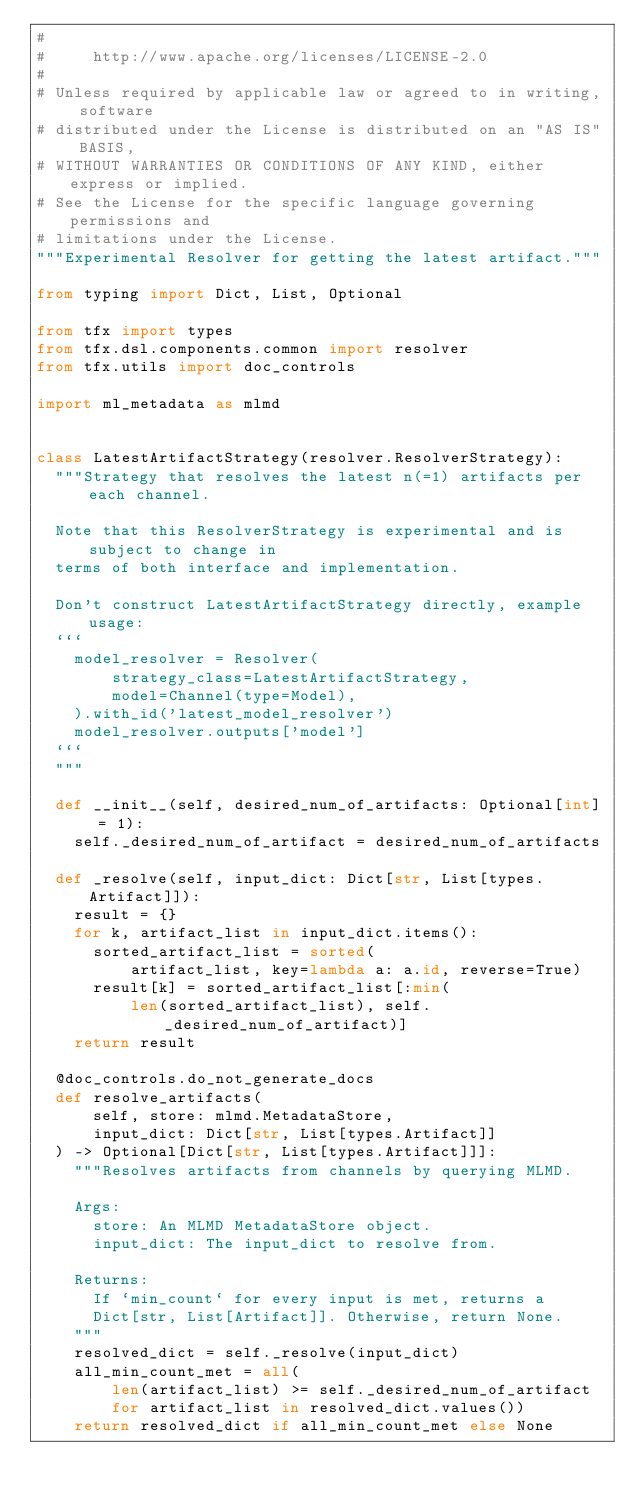<code> <loc_0><loc_0><loc_500><loc_500><_Python_>#
#     http://www.apache.org/licenses/LICENSE-2.0
#
# Unless required by applicable law or agreed to in writing, software
# distributed under the License is distributed on an "AS IS" BASIS,
# WITHOUT WARRANTIES OR CONDITIONS OF ANY KIND, either express or implied.
# See the License for the specific language governing permissions and
# limitations under the License.
"""Experimental Resolver for getting the latest artifact."""

from typing import Dict, List, Optional

from tfx import types
from tfx.dsl.components.common import resolver
from tfx.utils import doc_controls

import ml_metadata as mlmd


class LatestArtifactStrategy(resolver.ResolverStrategy):
  """Strategy that resolves the latest n(=1) artifacts per each channel.

  Note that this ResolverStrategy is experimental and is subject to change in
  terms of both interface and implementation.

  Don't construct LatestArtifactStrategy directly, example usage:
  ```
    model_resolver = Resolver(
        strategy_class=LatestArtifactStrategy,
        model=Channel(type=Model),
    ).with_id('latest_model_resolver')
    model_resolver.outputs['model']
  ```
  """

  def __init__(self, desired_num_of_artifacts: Optional[int] = 1):
    self._desired_num_of_artifact = desired_num_of_artifacts

  def _resolve(self, input_dict: Dict[str, List[types.Artifact]]):
    result = {}
    for k, artifact_list in input_dict.items():
      sorted_artifact_list = sorted(
          artifact_list, key=lambda a: a.id, reverse=True)
      result[k] = sorted_artifact_list[:min(
          len(sorted_artifact_list), self._desired_num_of_artifact)]
    return result

  @doc_controls.do_not_generate_docs
  def resolve_artifacts(
      self, store: mlmd.MetadataStore,
      input_dict: Dict[str, List[types.Artifact]]
  ) -> Optional[Dict[str, List[types.Artifact]]]:
    """Resolves artifacts from channels by querying MLMD.

    Args:
      store: An MLMD MetadataStore object.
      input_dict: The input_dict to resolve from.

    Returns:
      If `min_count` for every input is met, returns a
      Dict[str, List[Artifact]]. Otherwise, return None.
    """
    resolved_dict = self._resolve(input_dict)
    all_min_count_met = all(
        len(artifact_list) >= self._desired_num_of_artifact
        for artifact_list in resolved_dict.values())
    return resolved_dict if all_min_count_met else None
</code> 